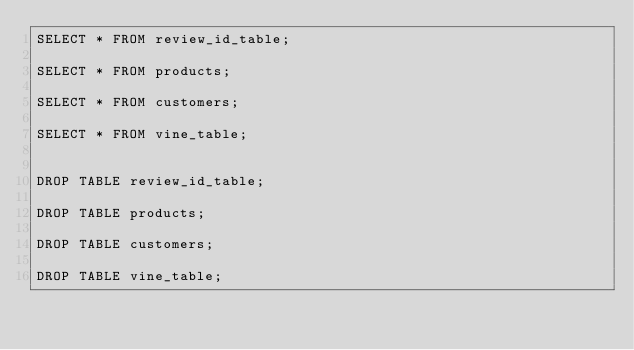Convert code to text. <code><loc_0><loc_0><loc_500><loc_500><_SQL_>SELECT * FROM review_id_table;

SELECT * FROM products;

SELECT * FROM customers;

SELECT * FROM vine_table;


DROP TABLE review_id_table;

DROP TABLE products;

DROP TABLE customers;

DROP TABLE vine_table;

</code> 